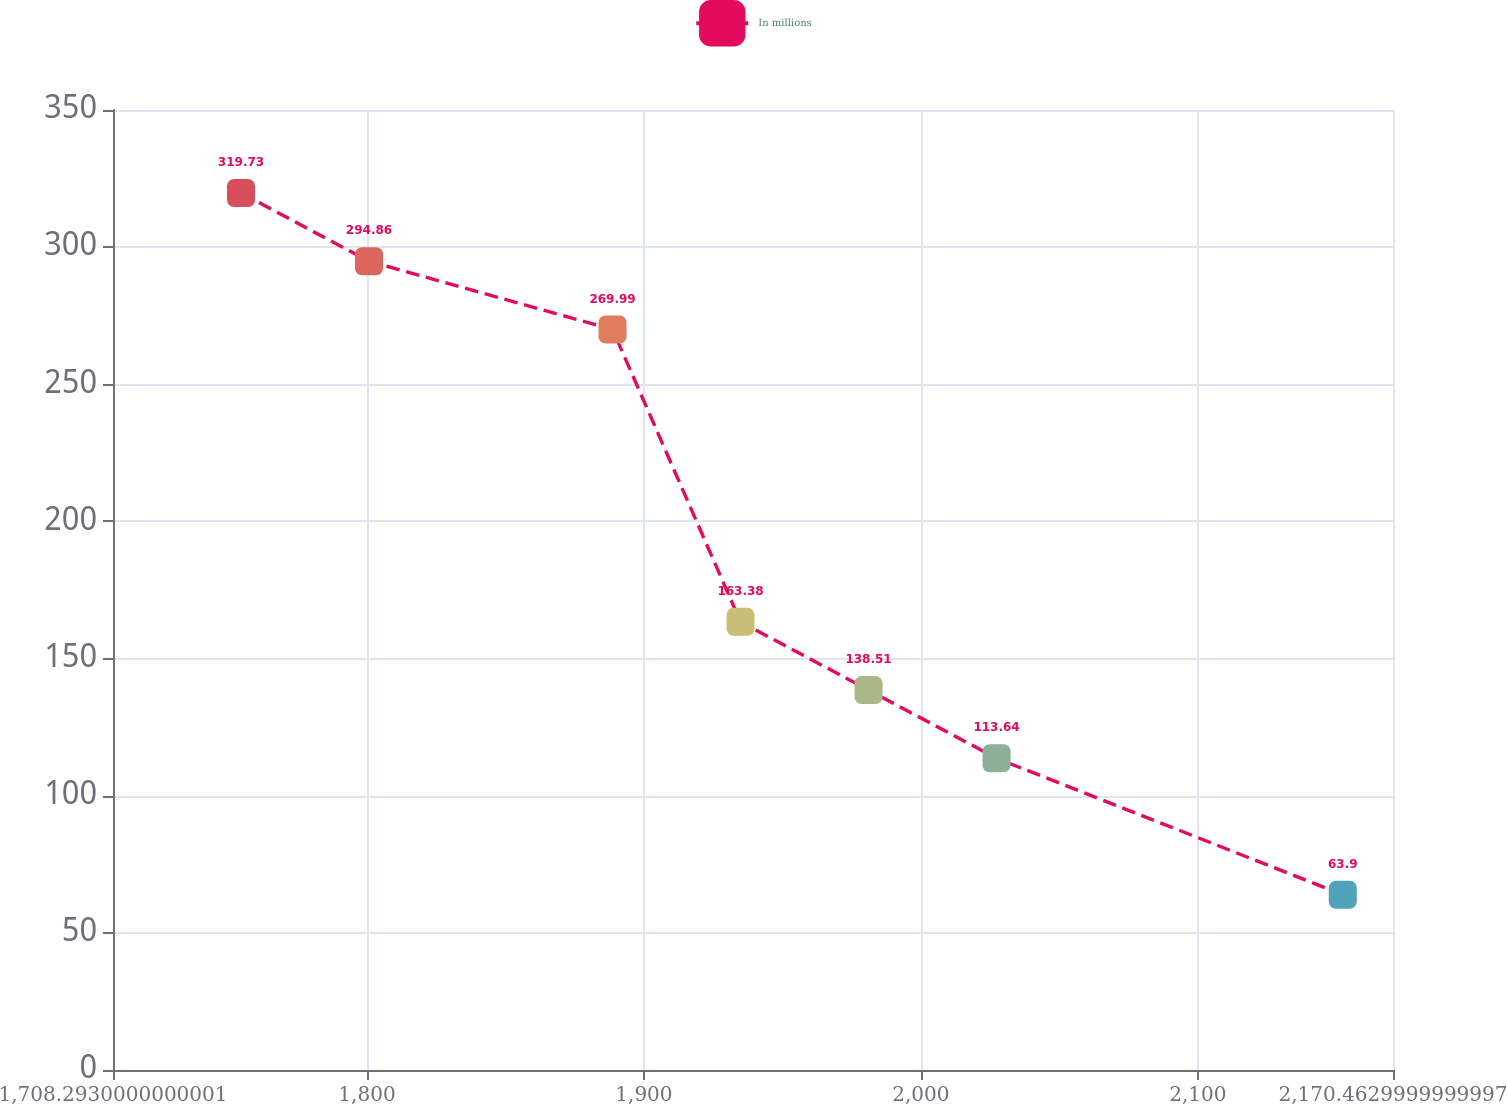Convert chart to OTSL. <chart><loc_0><loc_0><loc_500><loc_500><line_chart><ecel><fcel>In millions<nl><fcel>1754.51<fcel>319.73<nl><fcel>1800.73<fcel>294.86<nl><fcel>1888.66<fcel>269.99<nl><fcel>1934.88<fcel>163.38<nl><fcel>1981.1<fcel>138.51<nl><fcel>2027.32<fcel>113.64<nl><fcel>2152.33<fcel>63.9<nl><fcel>2216.68<fcel>88.77<nl></chart> 